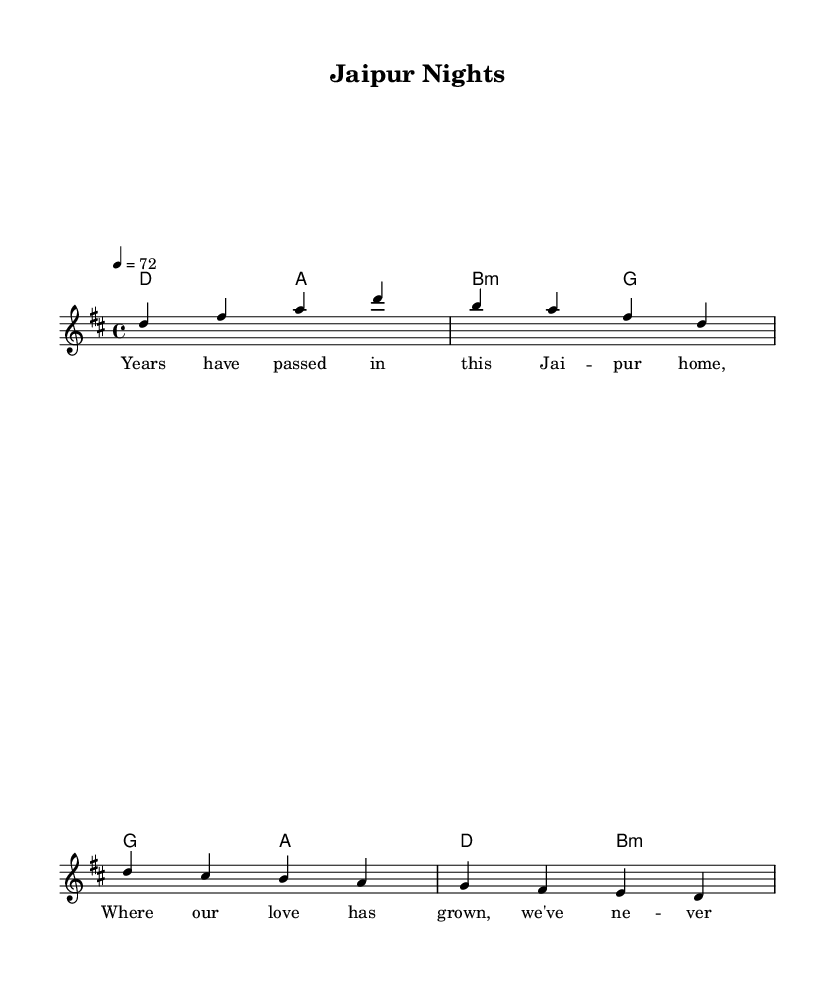What is the key signature of this music? The key signature is identified as D major, which includes two sharps (F# and C#). The music notation typically indicates the key at the beginning, and in this case, it shows a "D" followed by a major symbol, confirming D major.
Answer: D major What is the time signature of this music? The time signature is indicated by the notation at the beginning of the score showing "4/4." This means there are four beats per measure, and the quarter note gets one beat, which is standard in many styles of music, including rock.
Answer: 4/4 What is the tempo marking for this piece? The tempo marking is specified as "4 = 72," which indicates that a quarter note is set to a speed of 72 beats per minute. This is typically placed at the top of the sheet music and suggests a moderate pace for the performance.
Answer: 72 Which chord is used in the first measure of the harmonies? The first chord indicated in the harmonic section is D major. This can be deduced from the chord mode notation starting with "d2" in the first measure shown in a chord format, where "d" represents the D major chord.
Answer: D major How many lyrics lines are there in the verse? The verse section has two lines of lyrics, which can be observed by counting the distinct lyric phrases under the melody notes. Each line corresponds to a segment of the melody verse in the song structure.
Answer: 2 What is the relationship described in the lyrics? The relationship described in the lyrics emphasizes commitment and the passage of time, reflecting on love and companionship in a shared space. This idea is conveyed through phrases like "Years have passed" and "our bond stays strong," indicating a long-term romantic connection.
Answer: Commitment 